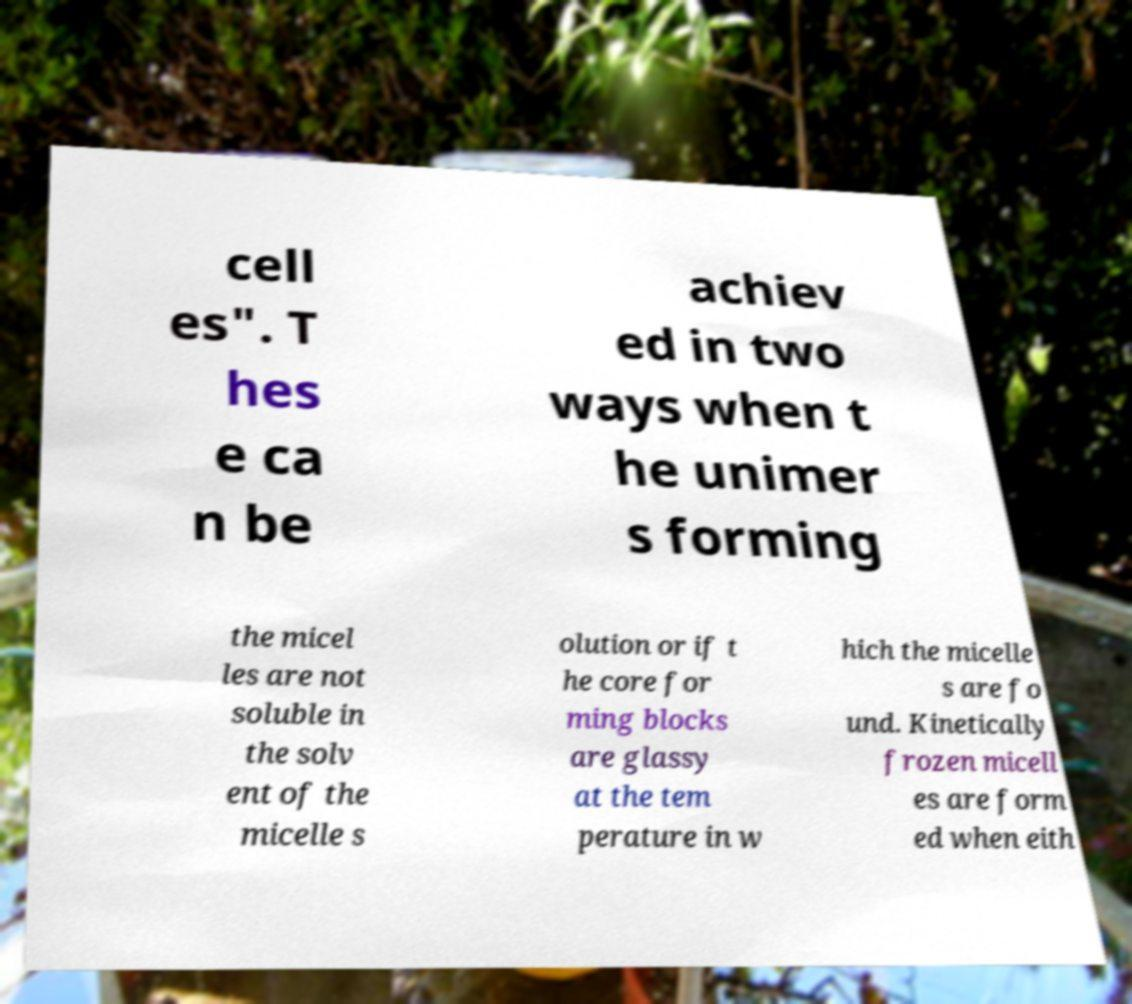There's text embedded in this image that I need extracted. Can you transcribe it verbatim? cell es". T hes e ca n be achiev ed in two ways when t he unimer s forming the micel les are not soluble in the solv ent of the micelle s olution or if t he core for ming blocks are glassy at the tem perature in w hich the micelle s are fo und. Kinetically frozen micell es are form ed when eith 